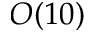<formula> <loc_0><loc_0><loc_500><loc_500>O ( 1 0 )</formula> 